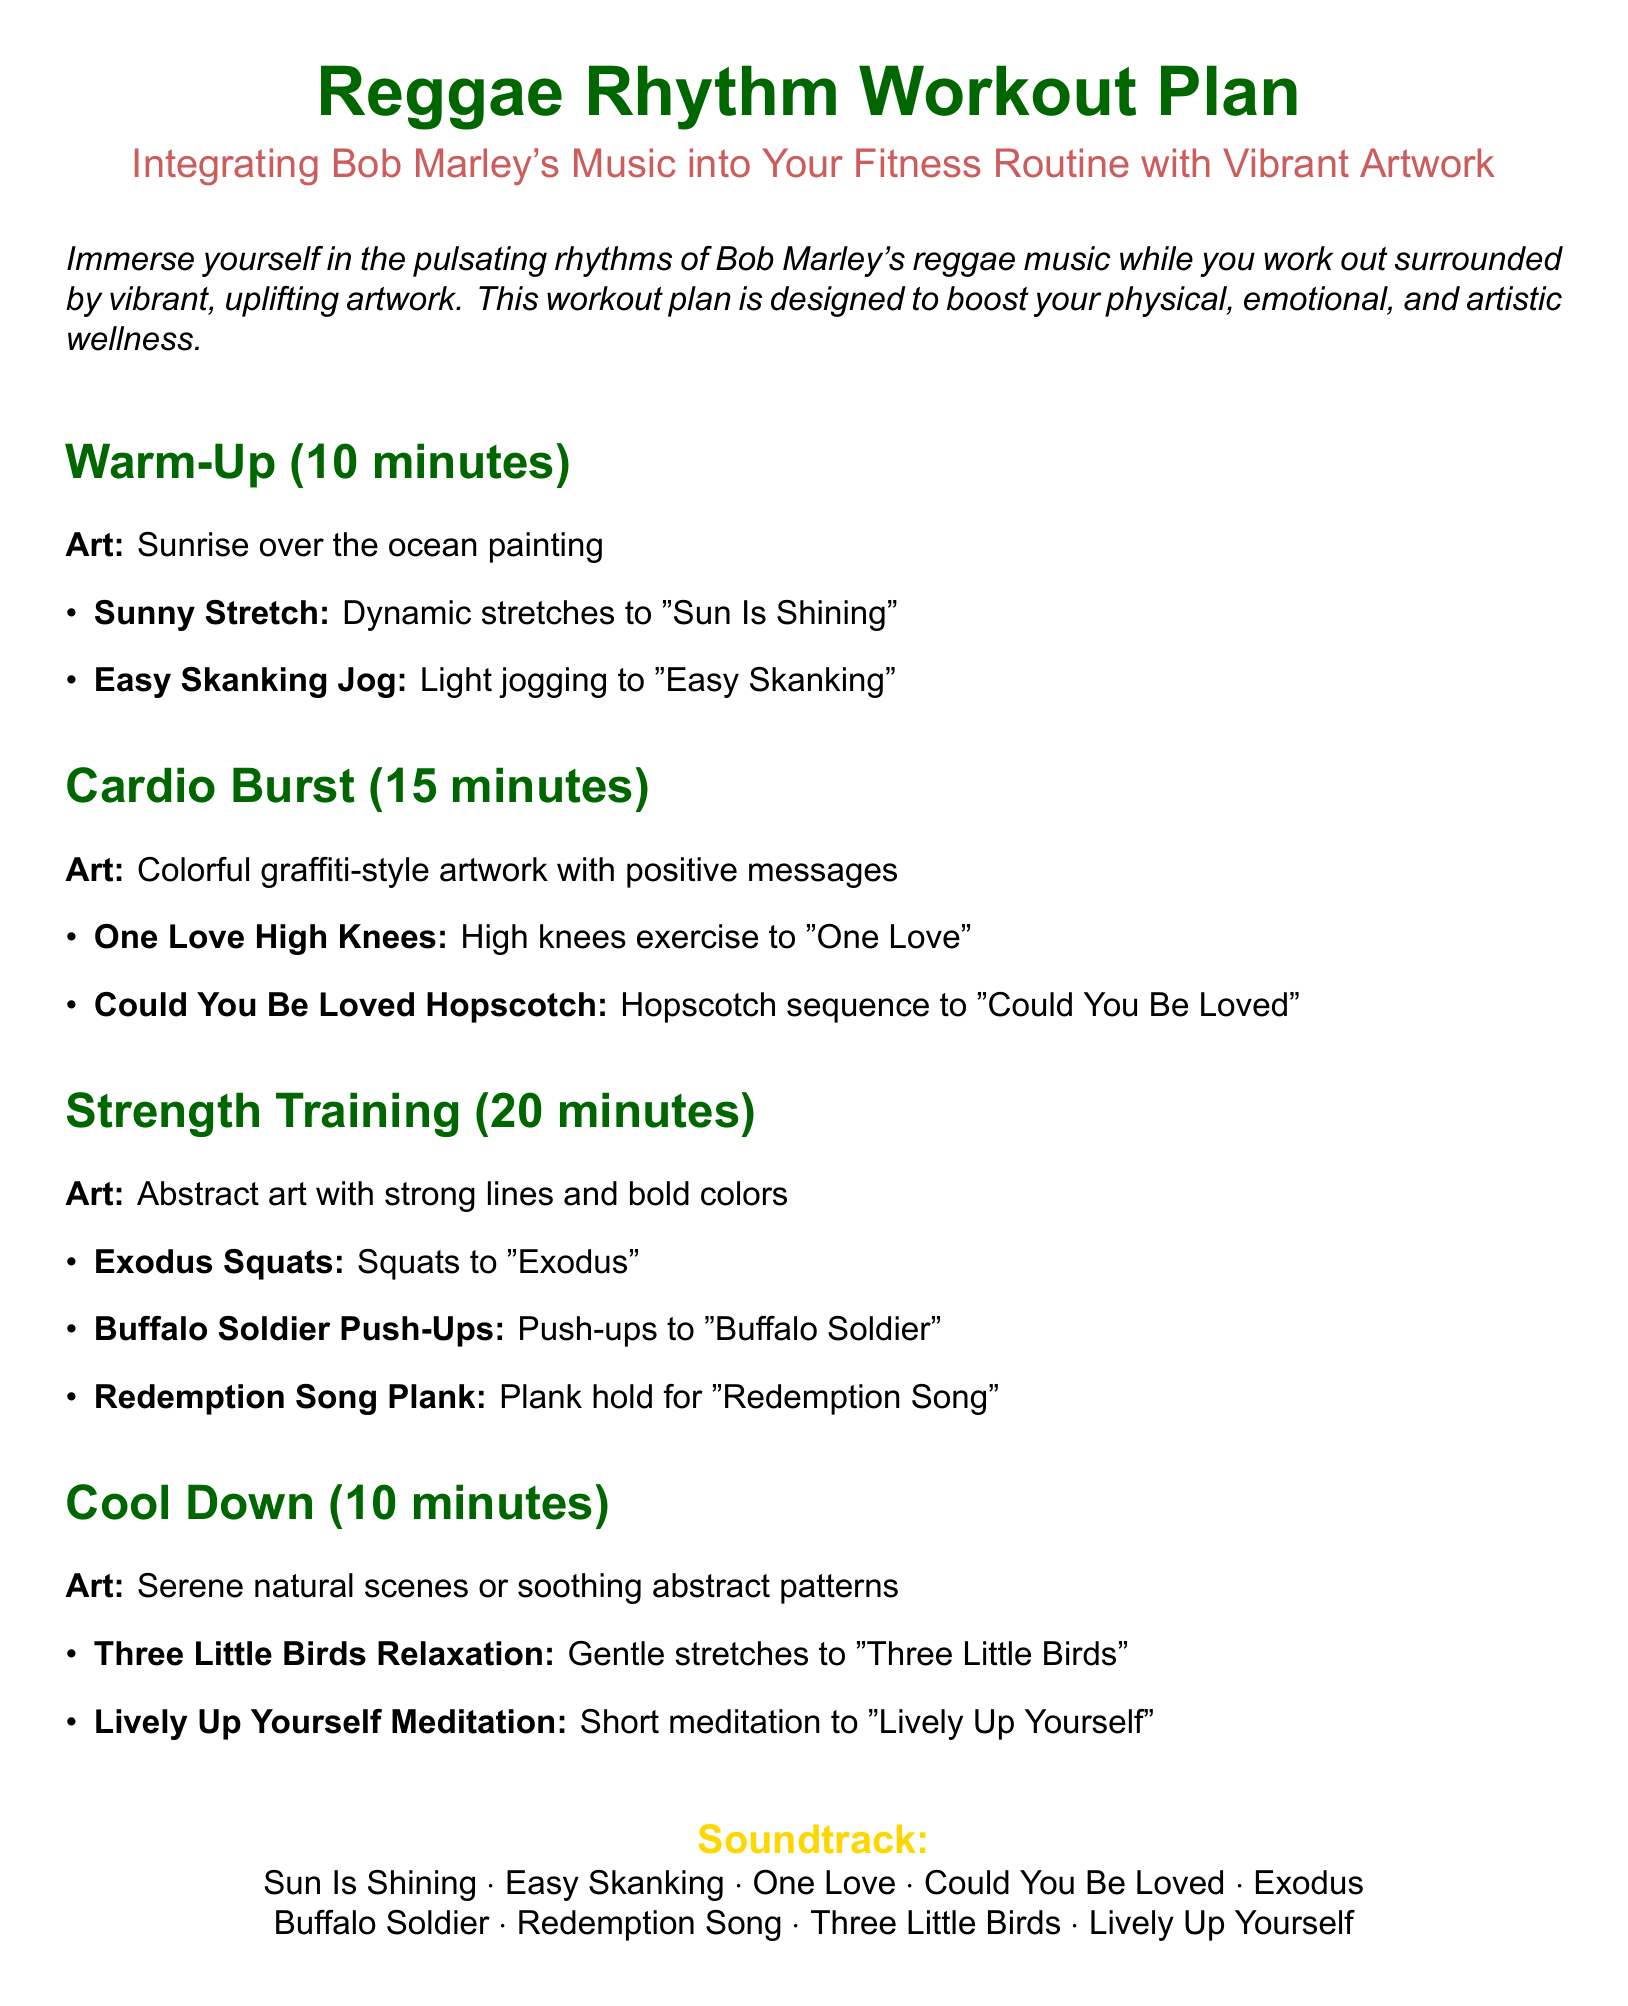What is the duration of the warm-up? The warm-up section states it lasts for 10 minutes.
Answer: 10 minutes Which Bob Marley song is associated with the high knees exercise? The document mentions "One Love" for the high knees exercise.
Answer: One Love How long is the strength training segment? The strength training section specifies a duration of 20 minutes.
Answer: 20 minutes What type of artwork is suggested for the cardio burst section? The document describes colorful graffiti-style artwork for this part.
Answer: Colorful graffiti-style artwork What exercise is paired with the song "Redemption Song"? The workout plan indicates a plank hold for "Redemption Song".
Answer: Plank hold What is the total duration of the workout plan? The total is calculated by adding the duration of each section: 10 + 15 + 20 + 10 = 55 minutes.
Answer: 55 minutes Name one relaxation exercise from the cool down section. The document lists "Three Little Birds Relaxation" as a relaxation exercise.
Answer: Three Little Birds Relaxation What art theme is associated with the cool down? The cool down section mentions serene natural scenes or soothing abstract patterns as the art theme.
Answer: Serene natural scenes How many songs are part of the soundtrack? The document lists a total of eight songs in the soundtrack section.
Answer: Eight songs 